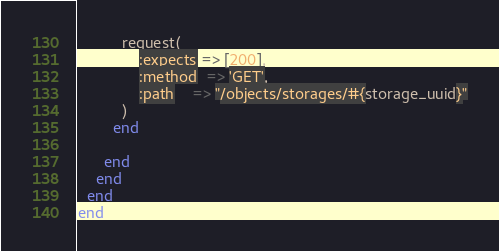Convert code to text. <code><loc_0><loc_0><loc_500><loc_500><_Ruby_>          request(
              :expects => [200],
              :method  => 'GET',
              :path    => "/objects/storages/#{storage_uuid}"
          )
        end

      end
    end
  end
end
</code> 